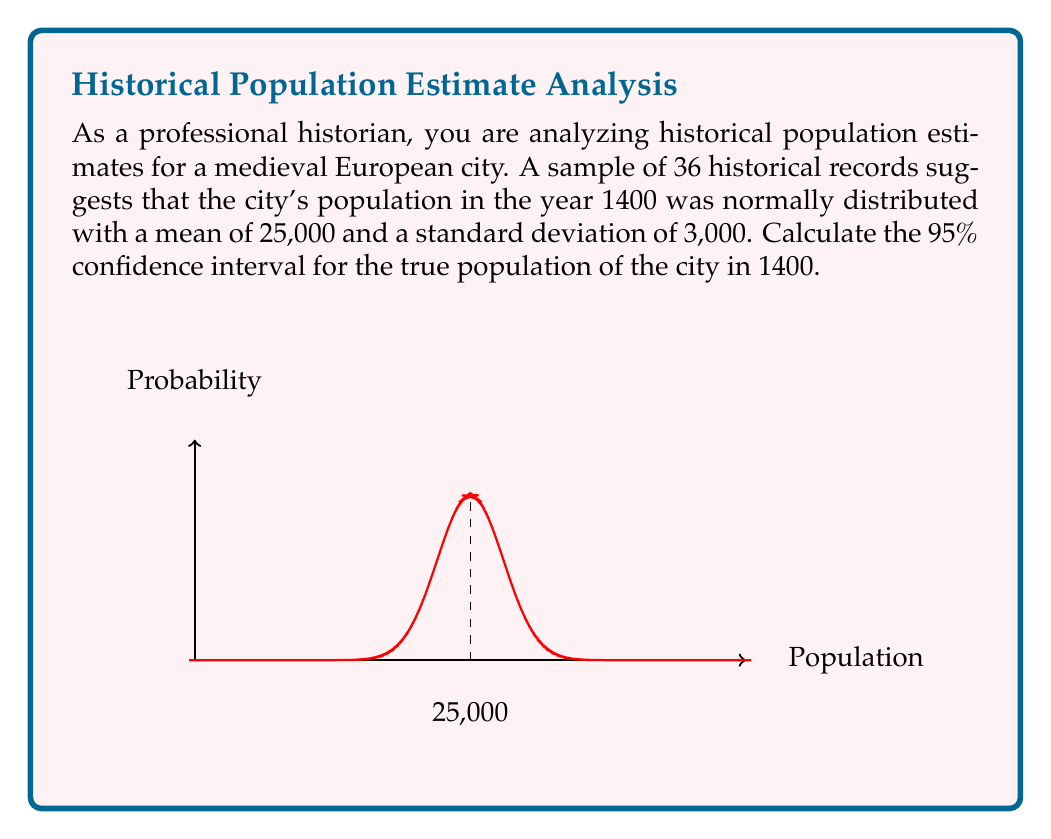Provide a solution to this math problem. To calculate the confidence interval, we'll follow these steps:

1) The formula for a confidence interval is:

   $$ \bar{x} \pm z \cdot \frac{\sigma}{\sqrt{n}} $$

   where $\bar{x}$ is the sample mean, $z$ is the z-score for the desired confidence level, $\sigma$ is the population standard deviation, and $n$ is the sample size.

2) We're given:
   - $\bar{x} = 25,000$
   - $\sigma = 3,000$
   - $n = 36$
   - Confidence level = 95%

3) For a 95% confidence interval, the z-score is 1.96.

4) Let's substitute these values into the formula:

   $$ 25,000 \pm 1.96 \cdot \frac{3,000}{\sqrt{36}} $$

5) Simplify:
   $$ 25,000 \pm 1.96 \cdot \frac{3,000}{6} $$
   $$ 25,000 \pm 1.96 \cdot 500 $$
   $$ 25,000 \pm 980 $$

6) Calculate the lower and upper bounds:
   Lower bound: $25,000 - 980 = 24,020$
   Upper bound: $25,000 + 980 = 25,980$

Therefore, we can say with 95% confidence that the true population of the city in 1400 was between 24,020 and 25,980.
Answer: (24,020, 25,980) 